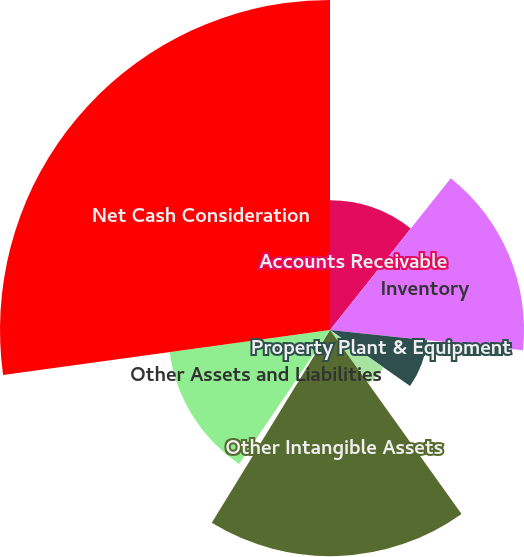Convert chart. <chart><loc_0><loc_0><loc_500><loc_500><pie_chart><fcel>Accounts Receivable<fcel>Inventory<fcel>Property Plant & Equipment<fcel>Goodwill<fcel>Other Intangible Assets<fcel>Accounts Payable<fcel>Other Assets and Liabilities<fcel>Net Cash Consideration<nl><fcel>10.69%<fcel>15.98%<fcel>8.05%<fcel>5.4%<fcel>18.63%<fcel>0.73%<fcel>13.34%<fcel>27.18%<nl></chart> 